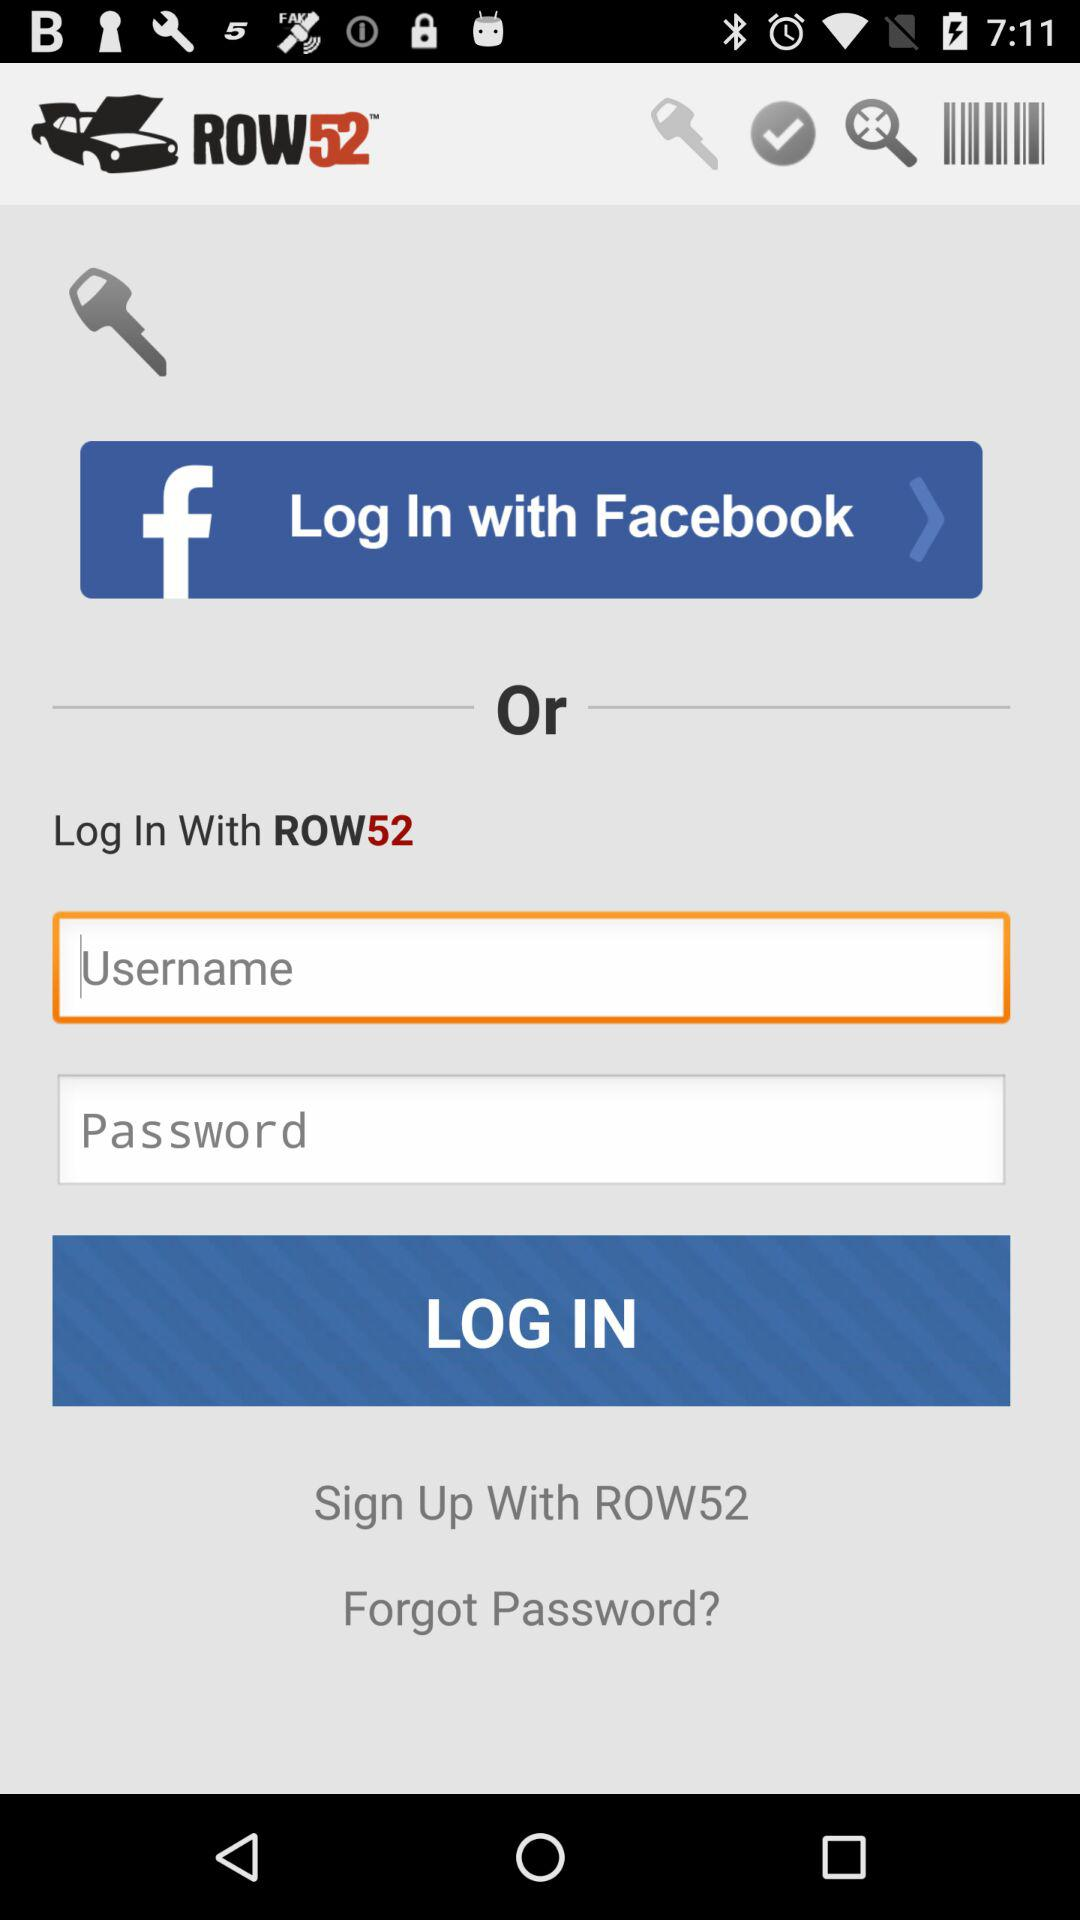How many text input fields are there on the screen?
Answer the question using a single word or phrase. 2 